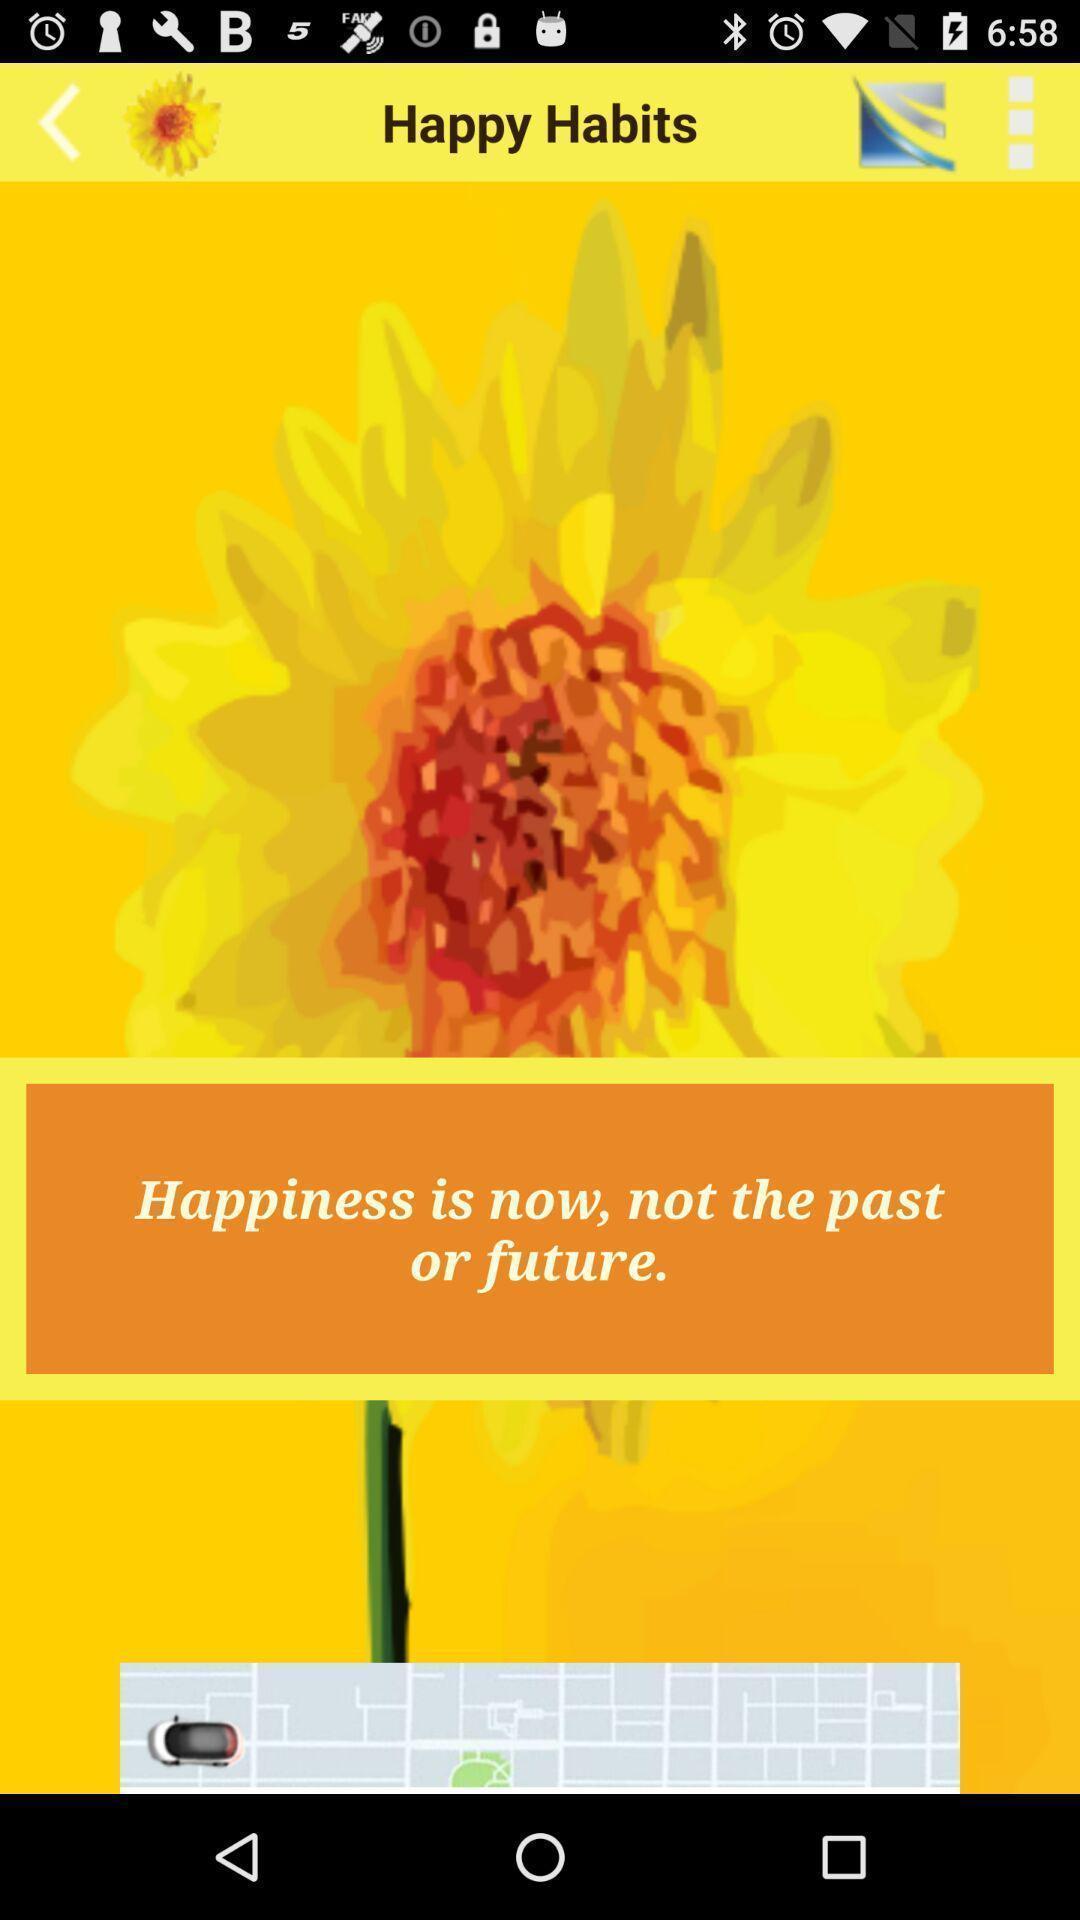Tell me about the visual elements in this screen capture. Screen shows multiple options. 